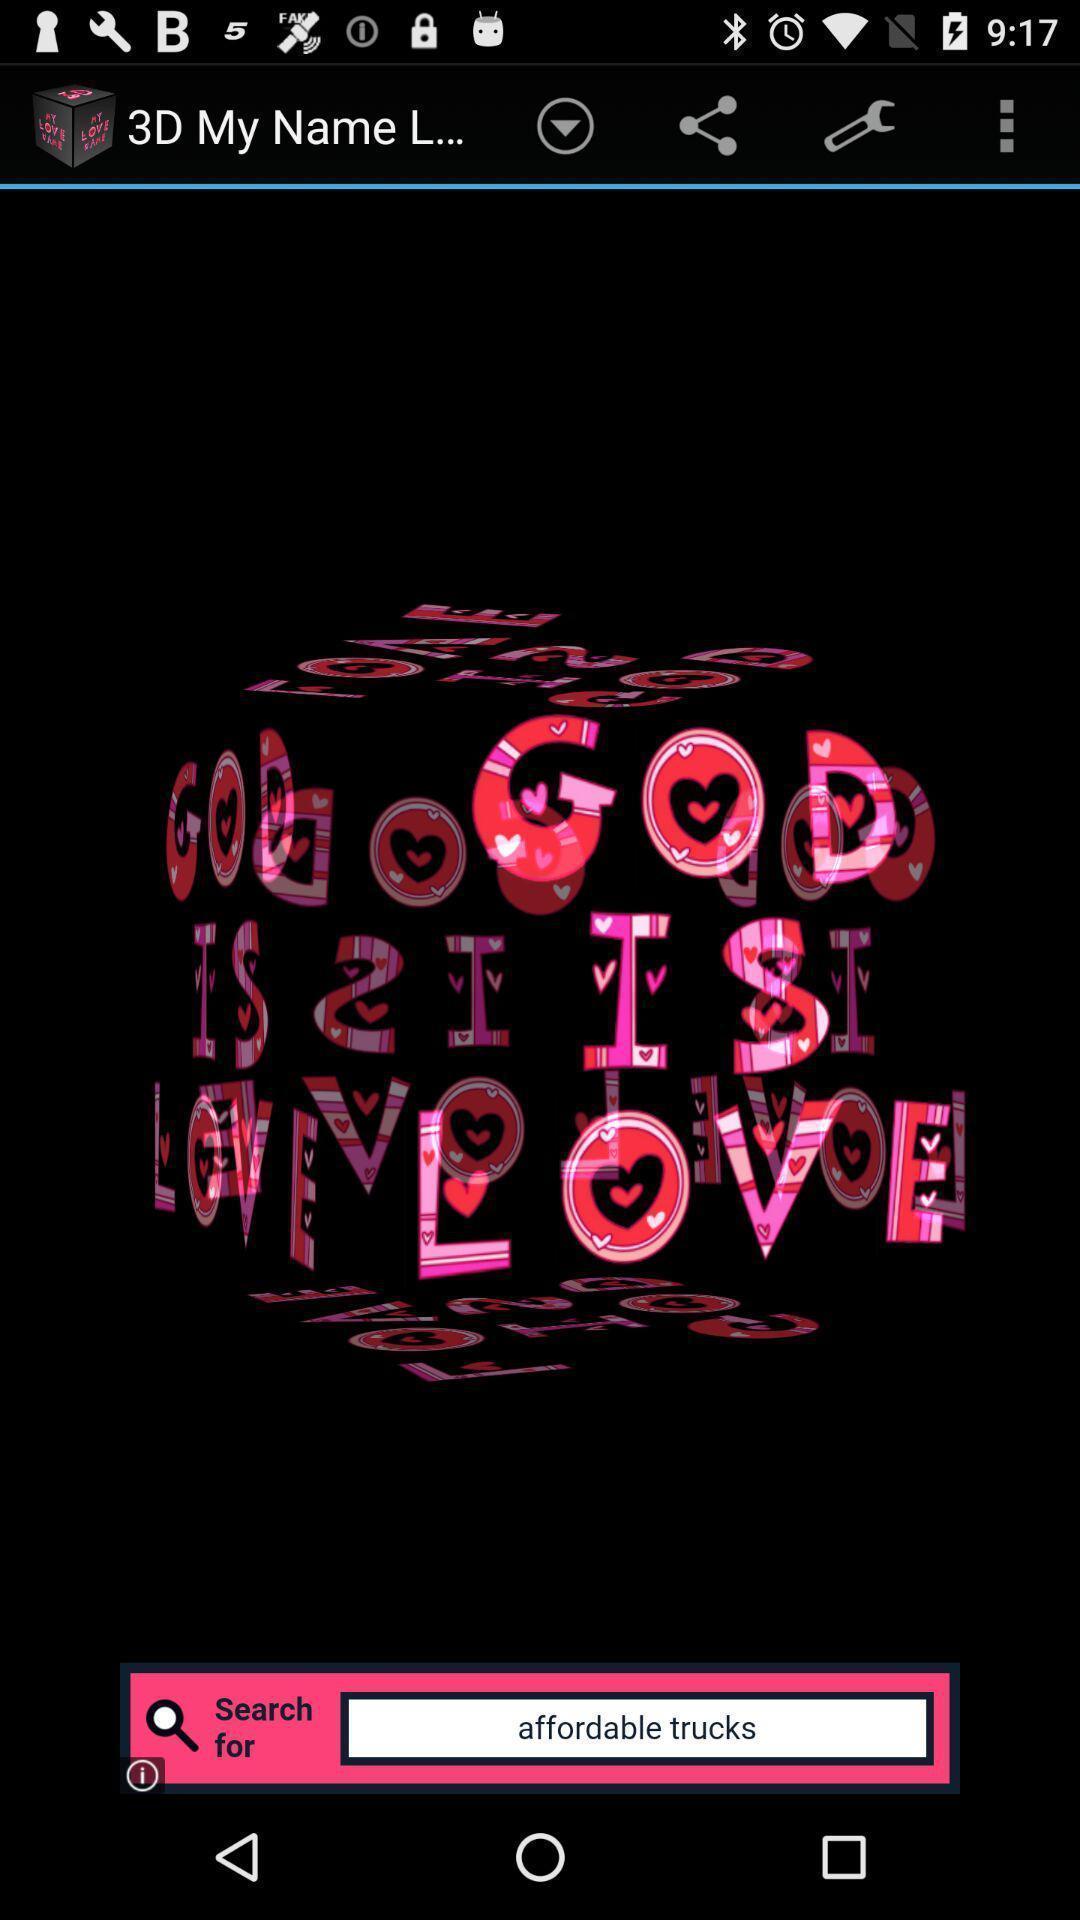Give me a summary of this screen capture. Screen displaying a search bar and other multiple controls. 